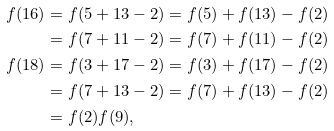<formula> <loc_0><loc_0><loc_500><loc_500>f ( 1 6 ) & = f ( 5 + 1 3 - 2 ) = f ( 5 ) + f ( 1 3 ) - f ( 2 ) \\ & = f ( 7 + 1 1 - 2 ) = f ( 7 ) + f ( 1 1 ) - f ( 2 ) \\ f ( 1 8 ) & = f ( 3 + 1 7 - 2 ) = f ( 3 ) + f ( 1 7 ) - f ( 2 ) \\ & = f ( 7 + 1 3 - 2 ) = f ( 7 ) + f ( 1 3 ) - f ( 2 ) \\ & = f ( 2 ) f ( 9 ) ,</formula> 